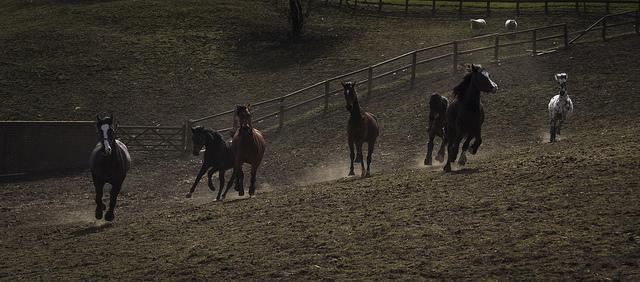What is used to keep the horses in one area?
Indicate the correct response by choosing from the four available options to answer the question.
Options: Trees, dogs, fences, guns. Fences. 